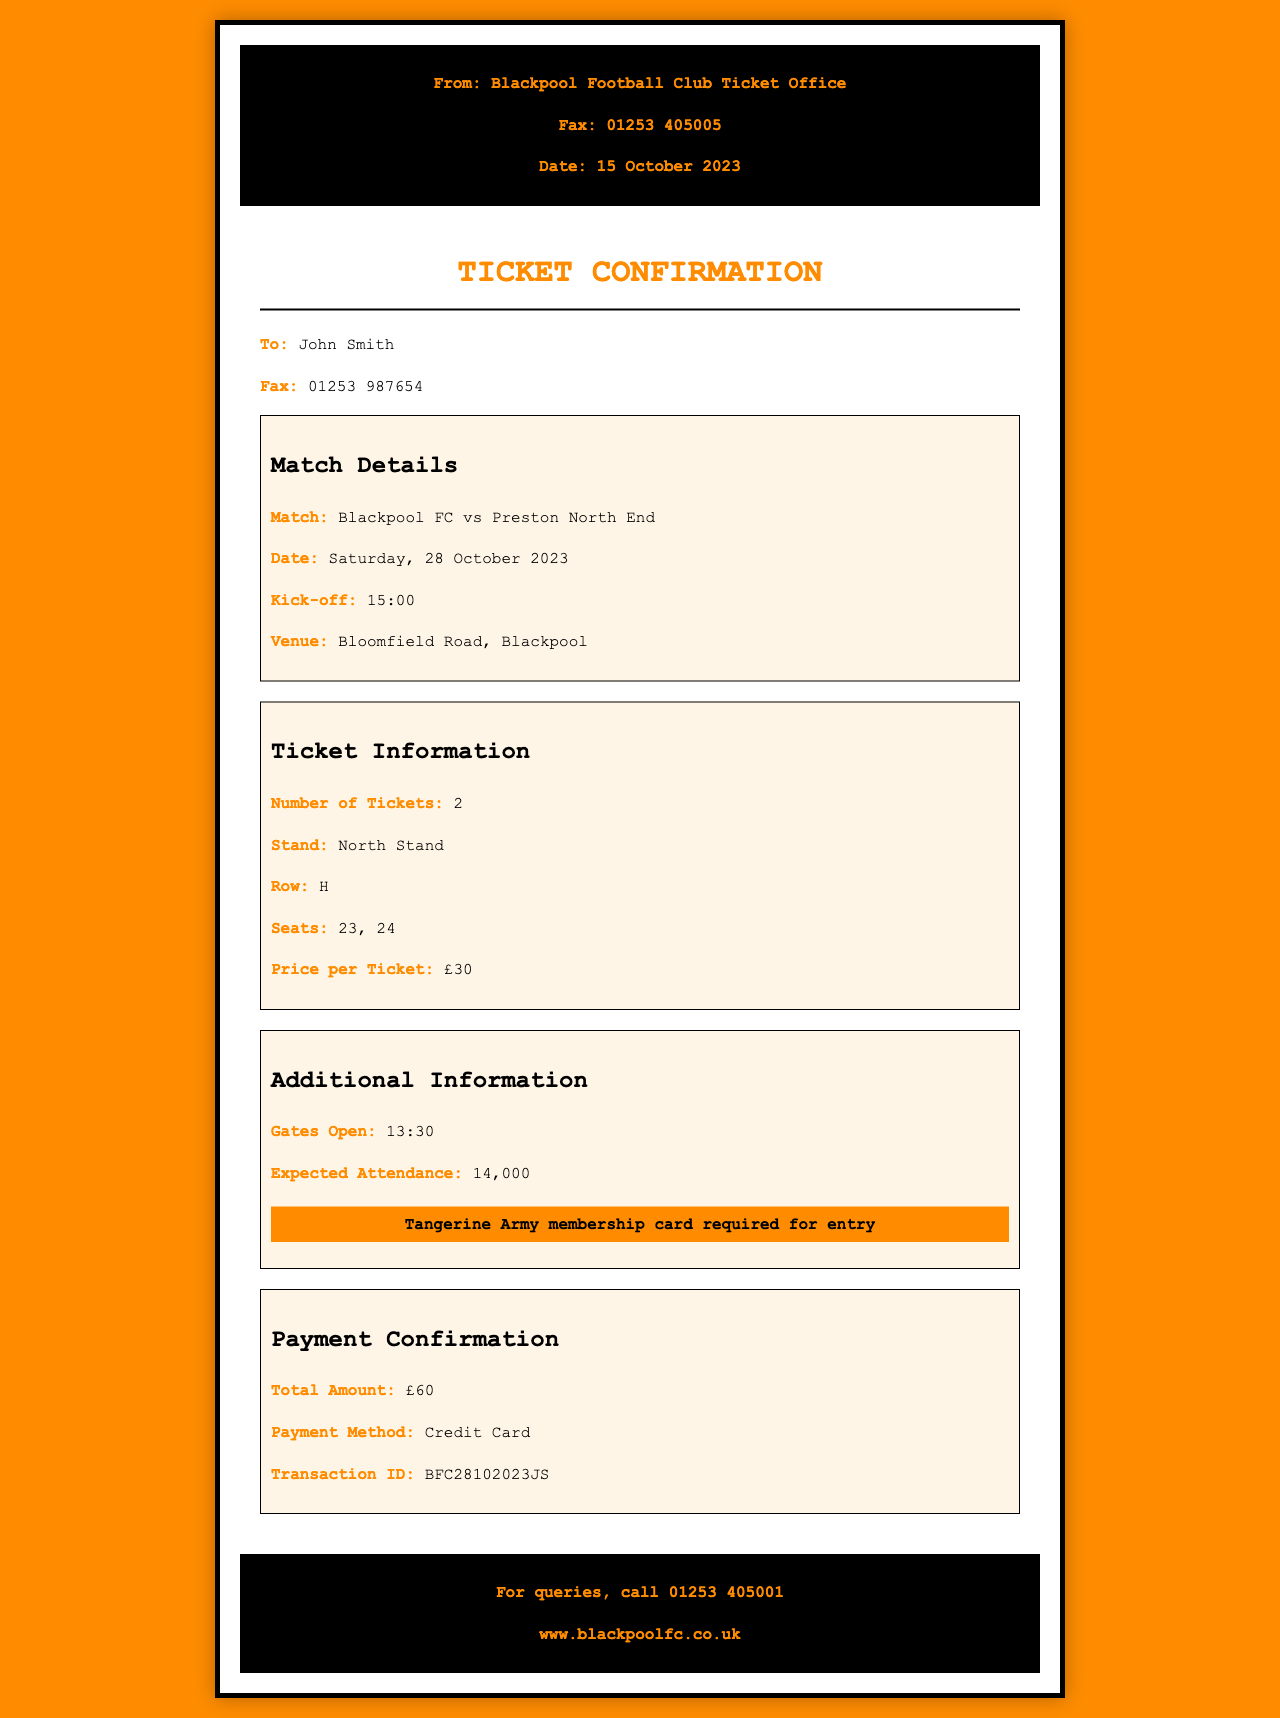what is the match date? The match date is specified in the document as Saturday, 28 October 2023.
Answer: Saturday, 28 October 2023 who is the recipient of the fax? The document states that the fax is addressed to John Smith.
Answer: John Smith how many tickets were purchased? The number of tickets is listed as 2 in the ticket information section.
Answer: 2 what is the kick-off time for the match? The kick-off time is provided in the match details and is 15:00.
Answer: 15:00 what is the total amount paid? The total amount is confirmed in the payment section as £60.
Answer: £60 which stand will the seats be in? The document specifies that the tickets are for the North Stand.
Answer: North Stand what is required for entry to the match? The document mentions that a Tangerine Army membership card is required for entry.
Answer: Tangerine Army membership card what is the seat number for one of the tickets? The seat numbers are noted in the ticket information, and one of them is 23.
Answer: 23 how is the payment made? The payment method is mentioned in the payment confirmation section as Credit Card.
Answer: Credit Card 